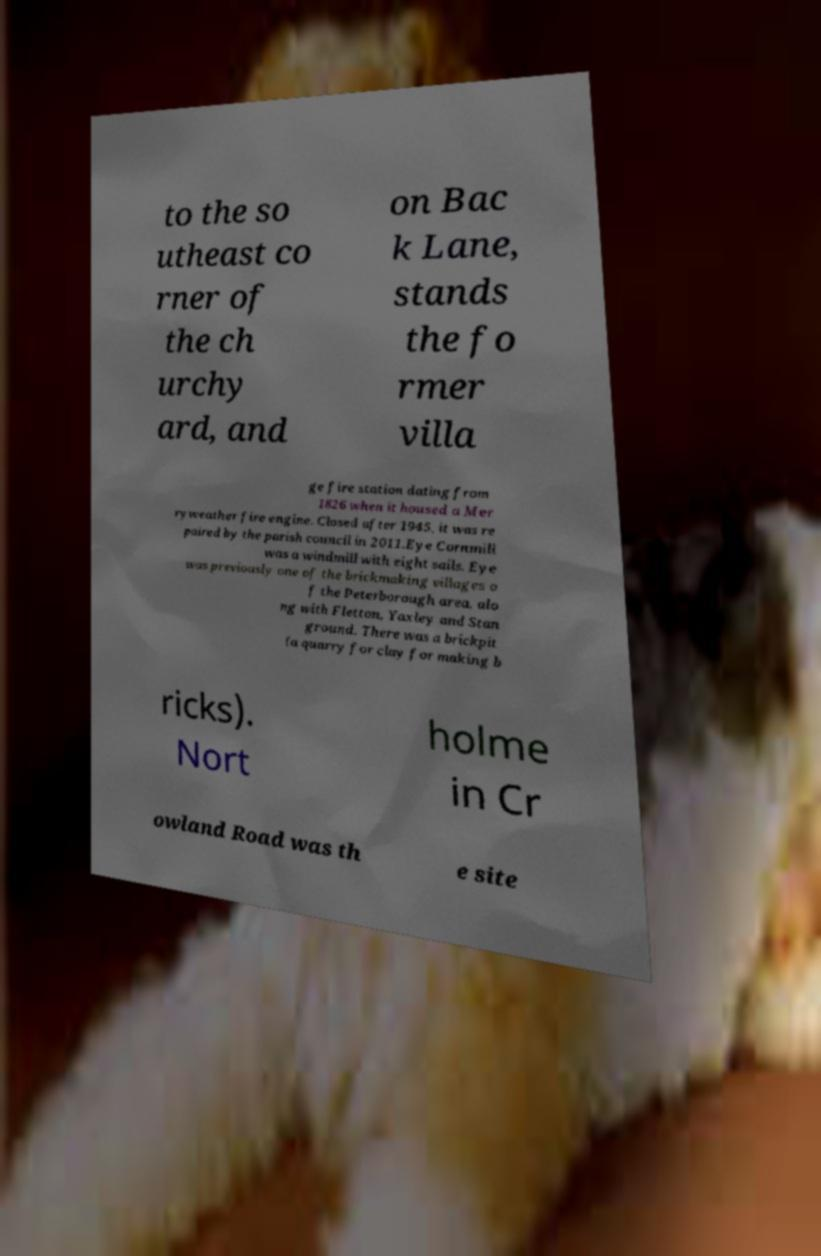Could you extract and type out the text from this image? to the so utheast co rner of the ch urchy ard, and on Bac k Lane, stands the fo rmer villa ge fire station dating from 1826 when it housed a Mer ryweather fire engine. Closed after 1945, it was re paired by the parish council in 2011.Eye Cornmill was a windmill with eight sails. Eye was previously one of the brickmaking villages o f the Peterborough area, alo ng with Fletton, Yaxley and Stan ground. There was a brickpit (a quarry for clay for making b ricks). Nort holme in Cr owland Road was th e site 